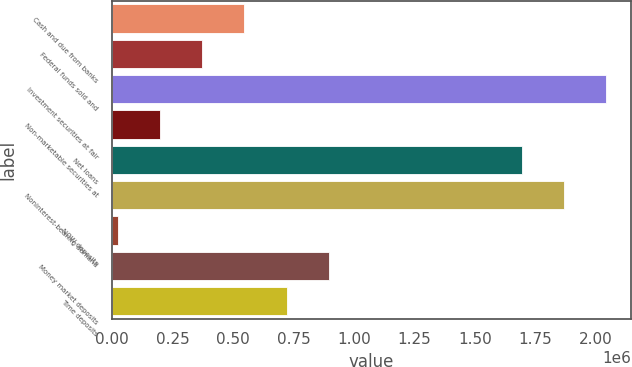Convert chart. <chart><loc_0><loc_0><loc_500><loc_500><bar_chart><fcel>Cash and due from banks<fcel>Federal funds sold and<fcel>Investment securities at fair<fcel>Non-marketable securities at<fcel>Net loans<fcel>Noninterest-bearing demand<fcel>NOW deposits<fcel>Money market deposits<fcel>Time deposits<nl><fcel>546063<fcel>372509<fcel>2.04177e+06<fcel>198955<fcel>1.69466e+06<fcel>1.86822e+06<fcel>25401<fcel>896518<fcel>722964<nl></chart> 